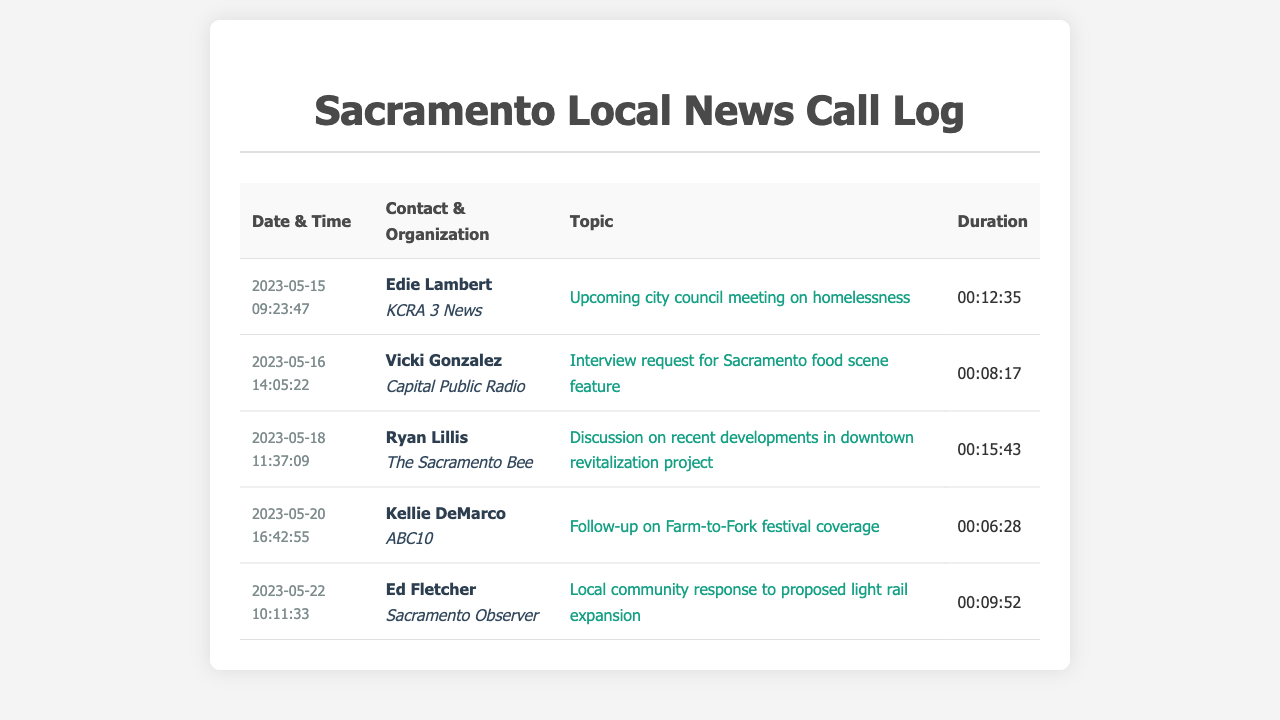What is the date and time of the call with Edie Lambert? The call with Edie Lambert occurred on May 15, 2023, at 09:23:47.
Answer: 2023-05-15 09:23:47 How long was the call with Vicki Gonzalez? The duration of the call with Vicki Gonzalez was 8 minutes and 17 seconds.
Answer: 00:08:17 Which organization does Ryan Lillis represent? Ryan Lillis is associated with The Sacramento Bee.
Answer: The Sacramento Bee What topic was discussed during the call with Kellie DeMarco? The call with Kellie DeMarco was about the Farm-to-Fork festival coverage.
Answer: Follow-up on Farm-to-Fork festival coverage Who was contacted about the light rail expansion proposal? Ed Fletcher from Sacramento Observer was contacted regarding the light rail expansion proposal.
Answer: Ed Fletcher Which call had the longest duration? The call with Ryan Lillis had the longest duration of 15 minutes and 43 seconds.
Answer: 00:15:43 What was the topic of the conversation with Edie Lambert? The topic of the conversation with Edie Lambert was about the upcoming city council meeting on homelessness.
Answer: Upcoming city council meeting on homelessness How many calls were made to KCRA 3 News? There was one call made to KCRA 3 News.
Answer: One 